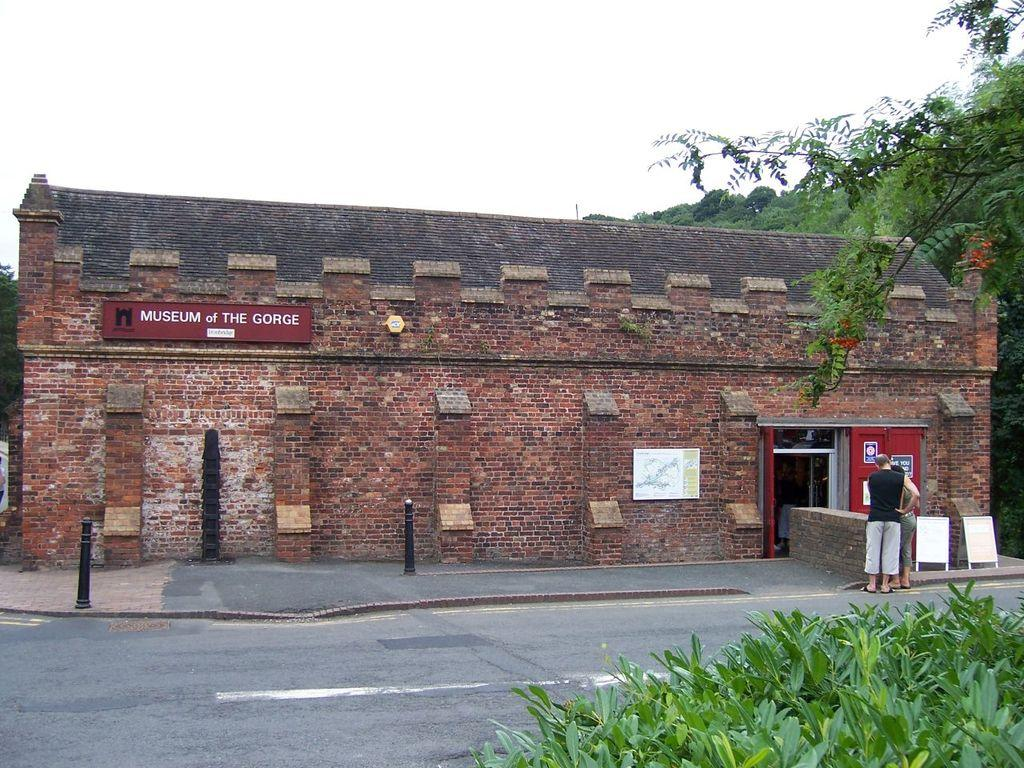What type of building is located on the right side of the image? There is a museum on the right side of the image. Can you describe the person in the image? A man is standing in the image, and he is wearing a black t-shirt. What can be seen in the background of the image? There is a road and trees on the right side of the image. What is visible at the top of the image? The sky is visible at the top of the image. What type of band can be seen playing on the road in the image? There is no band present in the image; it only shows a museum, a man, a road, trees, and the sky. Can you tell me how many ants are crawling on the man's glove in the image? There is no glove or ant present in the image. 